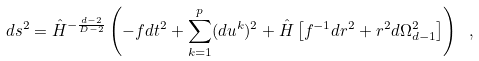<formula> <loc_0><loc_0><loc_500><loc_500>d s ^ { 2 } = \hat { H } ^ { - \frac { d - 2 } { D - 2 } } \left ( - f d t ^ { 2 } + \sum _ { k = 1 } ^ { p } ( d u ^ { k } ) ^ { 2 } + \hat { H } \left [ f ^ { - 1 } d r ^ { 2 } + r ^ { 2 } d \Omega _ { d - 1 } ^ { 2 } \right ] \right ) \ ,</formula> 